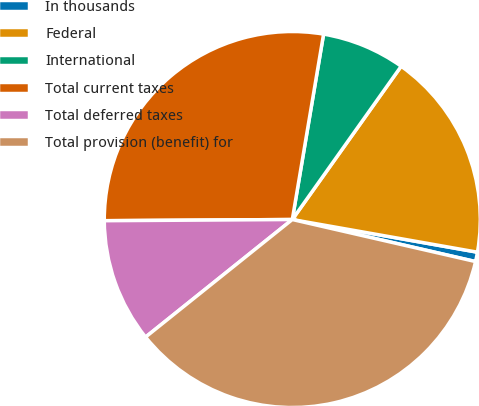<chart> <loc_0><loc_0><loc_500><loc_500><pie_chart><fcel>In thousands<fcel>Federal<fcel>International<fcel>Total current taxes<fcel>Total deferred taxes<fcel>Total provision (benefit) for<nl><fcel>0.81%<fcel>17.95%<fcel>7.17%<fcel>27.76%<fcel>10.65%<fcel>35.66%<nl></chart> 